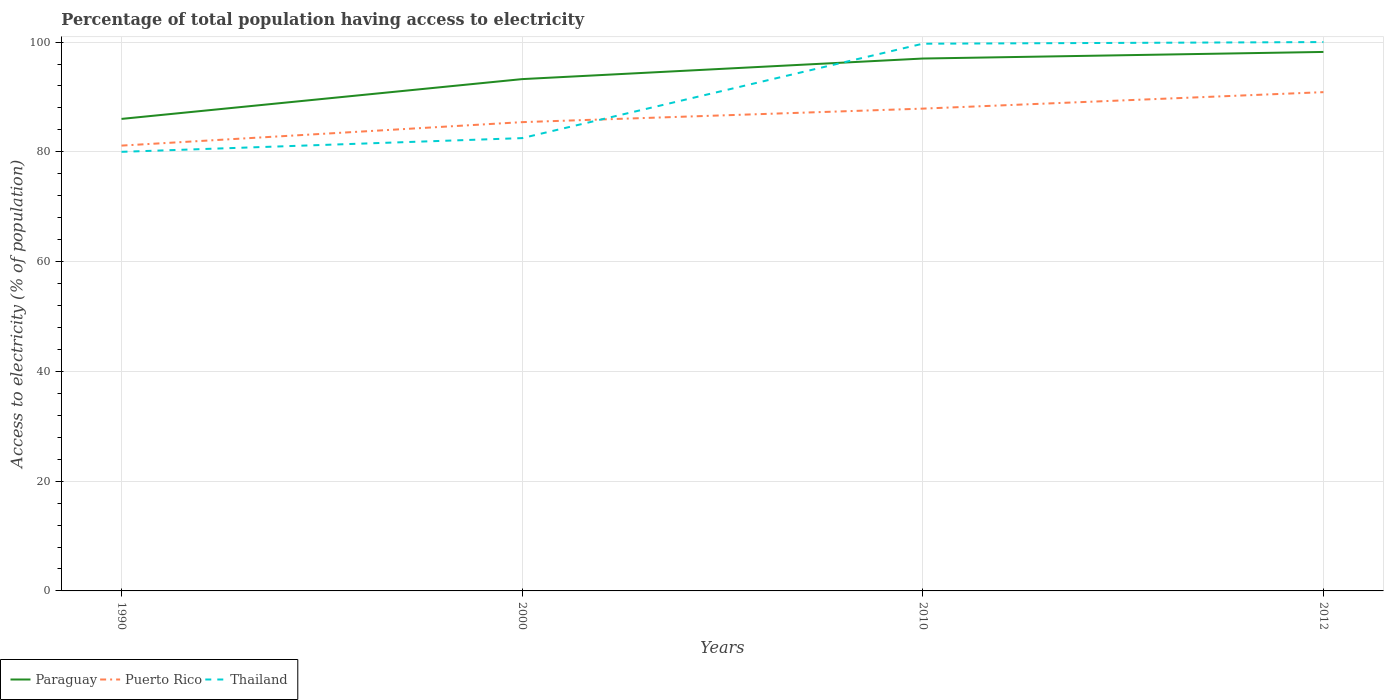How many different coloured lines are there?
Give a very brief answer. 3. Across all years, what is the maximum percentage of population that have access to electricity in Puerto Rico?
Your response must be concise. 81.14. What is the total percentage of population that have access to electricity in Puerto Rico in the graph?
Provide a succinct answer. -4.28. What is the difference between the highest and the second highest percentage of population that have access to electricity in Paraguay?
Ensure brevity in your answer.  12.2. Is the percentage of population that have access to electricity in Paraguay strictly greater than the percentage of population that have access to electricity in Thailand over the years?
Offer a terse response. No. How many lines are there?
Offer a terse response. 3. How many years are there in the graph?
Provide a succinct answer. 4. Does the graph contain grids?
Ensure brevity in your answer.  Yes. Where does the legend appear in the graph?
Provide a succinct answer. Bottom left. What is the title of the graph?
Ensure brevity in your answer.  Percentage of total population having access to electricity. What is the label or title of the Y-axis?
Give a very brief answer. Access to electricity (% of population). What is the Access to electricity (% of population) of Puerto Rico in 1990?
Keep it short and to the point. 81.14. What is the Access to electricity (% of population) in Thailand in 1990?
Provide a succinct answer. 80. What is the Access to electricity (% of population) of Paraguay in 2000?
Provide a succinct answer. 93.25. What is the Access to electricity (% of population) in Puerto Rico in 2000?
Make the answer very short. 85.41. What is the Access to electricity (% of population) in Thailand in 2000?
Offer a very short reply. 82.5. What is the Access to electricity (% of population) in Paraguay in 2010?
Provide a short and direct response. 97. What is the Access to electricity (% of population) of Puerto Rico in 2010?
Offer a terse response. 87.87. What is the Access to electricity (% of population) in Thailand in 2010?
Your response must be concise. 99.7. What is the Access to electricity (% of population) in Paraguay in 2012?
Offer a terse response. 98.2. What is the Access to electricity (% of population) in Puerto Rico in 2012?
Provide a succinct answer. 90.88. Across all years, what is the maximum Access to electricity (% of population) in Paraguay?
Make the answer very short. 98.2. Across all years, what is the maximum Access to electricity (% of population) of Puerto Rico?
Your response must be concise. 90.88. Across all years, what is the minimum Access to electricity (% of population) of Paraguay?
Your response must be concise. 86. Across all years, what is the minimum Access to electricity (% of population) of Puerto Rico?
Keep it short and to the point. 81.14. What is the total Access to electricity (% of population) in Paraguay in the graph?
Your answer should be compact. 374.45. What is the total Access to electricity (% of population) of Puerto Rico in the graph?
Make the answer very short. 345.3. What is the total Access to electricity (% of population) in Thailand in the graph?
Offer a terse response. 362.2. What is the difference between the Access to electricity (% of population) of Paraguay in 1990 and that in 2000?
Give a very brief answer. -7.25. What is the difference between the Access to electricity (% of population) of Puerto Rico in 1990 and that in 2000?
Provide a succinct answer. -4.28. What is the difference between the Access to electricity (% of population) of Paraguay in 1990 and that in 2010?
Provide a succinct answer. -11. What is the difference between the Access to electricity (% of population) in Puerto Rico in 1990 and that in 2010?
Offer a terse response. -6.74. What is the difference between the Access to electricity (% of population) of Thailand in 1990 and that in 2010?
Provide a short and direct response. -19.7. What is the difference between the Access to electricity (% of population) in Puerto Rico in 1990 and that in 2012?
Ensure brevity in your answer.  -9.74. What is the difference between the Access to electricity (% of population) of Thailand in 1990 and that in 2012?
Your answer should be compact. -20. What is the difference between the Access to electricity (% of population) of Paraguay in 2000 and that in 2010?
Offer a very short reply. -3.75. What is the difference between the Access to electricity (% of population) of Puerto Rico in 2000 and that in 2010?
Offer a very short reply. -2.46. What is the difference between the Access to electricity (% of population) in Thailand in 2000 and that in 2010?
Your answer should be compact. -17.2. What is the difference between the Access to electricity (% of population) in Paraguay in 2000 and that in 2012?
Offer a terse response. -4.95. What is the difference between the Access to electricity (% of population) of Puerto Rico in 2000 and that in 2012?
Provide a short and direct response. -5.46. What is the difference between the Access to electricity (% of population) in Thailand in 2000 and that in 2012?
Offer a terse response. -17.5. What is the difference between the Access to electricity (% of population) in Paraguay in 2010 and that in 2012?
Your answer should be very brief. -1.2. What is the difference between the Access to electricity (% of population) in Puerto Rico in 2010 and that in 2012?
Make the answer very short. -3. What is the difference between the Access to electricity (% of population) in Paraguay in 1990 and the Access to electricity (% of population) in Puerto Rico in 2000?
Your answer should be very brief. 0.59. What is the difference between the Access to electricity (% of population) of Paraguay in 1990 and the Access to electricity (% of population) of Thailand in 2000?
Offer a very short reply. 3.5. What is the difference between the Access to electricity (% of population) in Puerto Rico in 1990 and the Access to electricity (% of population) in Thailand in 2000?
Make the answer very short. -1.36. What is the difference between the Access to electricity (% of population) in Paraguay in 1990 and the Access to electricity (% of population) in Puerto Rico in 2010?
Your answer should be compact. -1.87. What is the difference between the Access to electricity (% of population) of Paraguay in 1990 and the Access to electricity (% of population) of Thailand in 2010?
Provide a short and direct response. -13.7. What is the difference between the Access to electricity (% of population) in Puerto Rico in 1990 and the Access to electricity (% of population) in Thailand in 2010?
Your response must be concise. -18.56. What is the difference between the Access to electricity (% of population) of Paraguay in 1990 and the Access to electricity (% of population) of Puerto Rico in 2012?
Offer a terse response. -4.88. What is the difference between the Access to electricity (% of population) in Paraguay in 1990 and the Access to electricity (% of population) in Thailand in 2012?
Ensure brevity in your answer.  -14. What is the difference between the Access to electricity (% of population) in Puerto Rico in 1990 and the Access to electricity (% of population) in Thailand in 2012?
Ensure brevity in your answer.  -18.86. What is the difference between the Access to electricity (% of population) of Paraguay in 2000 and the Access to electricity (% of population) of Puerto Rico in 2010?
Your answer should be very brief. 5.38. What is the difference between the Access to electricity (% of population) in Paraguay in 2000 and the Access to electricity (% of population) in Thailand in 2010?
Your answer should be compact. -6.45. What is the difference between the Access to electricity (% of population) of Puerto Rico in 2000 and the Access to electricity (% of population) of Thailand in 2010?
Provide a short and direct response. -14.29. What is the difference between the Access to electricity (% of population) in Paraguay in 2000 and the Access to electricity (% of population) in Puerto Rico in 2012?
Offer a terse response. 2.37. What is the difference between the Access to electricity (% of population) of Paraguay in 2000 and the Access to electricity (% of population) of Thailand in 2012?
Offer a terse response. -6.75. What is the difference between the Access to electricity (% of population) in Puerto Rico in 2000 and the Access to electricity (% of population) in Thailand in 2012?
Keep it short and to the point. -14.59. What is the difference between the Access to electricity (% of population) in Paraguay in 2010 and the Access to electricity (% of population) in Puerto Rico in 2012?
Give a very brief answer. 6.12. What is the difference between the Access to electricity (% of population) in Puerto Rico in 2010 and the Access to electricity (% of population) in Thailand in 2012?
Ensure brevity in your answer.  -12.13. What is the average Access to electricity (% of population) in Paraguay per year?
Offer a very short reply. 93.61. What is the average Access to electricity (% of population) of Puerto Rico per year?
Keep it short and to the point. 86.32. What is the average Access to electricity (% of population) in Thailand per year?
Give a very brief answer. 90.55. In the year 1990, what is the difference between the Access to electricity (% of population) of Paraguay and Access to electricity (% of population) of Puerto Rico?
Your answer should be very brief. 4.86. In the year 1990, what is the difference between the Access to electricity (% of population) of Puerto Rico and Access to electricity (% of population) of Thailand?
Provide a short and direct response. 1.14. In the year 2000, what is the difference between the Access to electricity (% of population) of Paraguay and Access to electricity (% of population) of Puerto Rico?
Offer a terse response. 7.84. In the year 2000, what is the difference between the Access to electricity (% of population) in Paraguay and Access to electricity (% of population) in Thailand?
Your answer should be very brief. 10.75. In the year 2000, what is the difference between the Access to electricity (% of population) of Puerto Rico and Access to electricity (% of population) of Thailand?
Give a very brief answer. 2.91. In the year 2010, what is the difference between the Access to electricity (% of population) of Paraguay and Access to electricity (% of population) of Puerto Rico?
Provide a short and direct response. 9.13. In the year 2010, what is the difference between the Access to electricity (% of population) in Puerto Rico and Access to electricity (% of population) in Thailand?
Give a very brief answer. -11.83. In the year 2012, what is the difference between the Access to electricity (% of population) of Paraguay and Access to electricity (% of population) of Puerto Rico?
Provide a succinct answer. 7.32. In the year 2012, what is the difference between the Access to electricity (% of population) of Puerto Rico and Access to electricity (% of population) of Thailand?
Your response must be concise. -9.12. What is the ratio of the Access to electricity (% of population) of Paraguay in 1990 to that in 2000?
Offer a very short reply. 0.92. What is the ratio of the Access to electricity (% of population) of Puerto Rico in 1990 to that in 2000?
Offer a terse response. 0.95. What is the ratio of the Access to electricity (% of population) in Thailand in 1990 to that in 2000?
Offer a very short reply. 0.97. What is the ratio of the Access to electricity (% of population) of Paraguay in 1990 to that in 2010?
Provide a short and direct response. 0.89. What is the ratio of the Access to electricity (% of population) of Puerto Rico in 1990 to that in 2010?
Your answer should be very brief. 0.92. What is the ratio of the Access to electricity (% of population) of Thailand in 1990 to that in 2010?
Your answer should be very brief. 0.8. What is the ratio of the Access to electricity (% of population) of Paraguay in 1990 to that in 2012?
Offer a very short reply. 0.88. What is the ratio of the Access to electricity (% of population) of Puerto Rico in 1990 to that in 2012?
Provide a succinct answer. 0.89. What is the ratio of the Access to electricity (% of population) in Thailand in 1990 to that in 2012?
Make the answer very short. 0.8. What is the ratio of the Access to electricity (% of population) in Paraguay in 2000 to that in 2010?
Ensure brevity in your answer.  0.96. What is the ratio of the Access to electricity (% of population) of Thailand in 2000 to that in 2010?
Your answer should be very brief. 0.83. What is the ratio of the Access to electricity (% of population) of Paraguay in 2000 to that in 2012?
Offer a very short reply. 0.95. What is the ratio of the Access to electricity (% of population) in Puerto Rico in 2000 to that in 2012?
Your answer should be compact. 0.94. What is the ratio of the Access to electricity (% of population) in Thailand in 2000 to that in 2012?
Provide a succinct answer. 0.82. What is the ratio of the Access to electricity (% of population) of Paraguay in 2010 to that in 2012?
Provide a short and direct response. 0.99. What is the ratio of the Access to electricity (% of population) in Puerto Rico in 2010 to that in 2012?
Offer a very short reply. 0.97. What is the ratio of the Access to electricity (% of population) in Thailand in 2010 to that in 2012?
Your response must be concise. 1. What is the difference between the highest and the second highest Access to electricity (% of population) of Paraguay?
Provide a succinct answer. 1.2. What is the difference between the highest and the second highest Access to electricity (% of population) of Puerto Rico?
Provide a short and direct response. 3. What is the difference between the highest and the lowest Access to electricity (% of population) of Puerto Rico?
Ensure brevity in your answer.  9.74. 